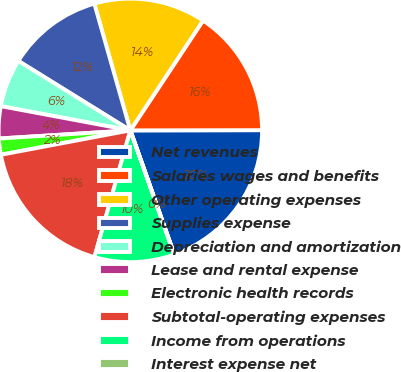Convert chart. <chart><loc_0><loc_0><loc_500><loc_500><pie_chart><fcel>Net revenues<fcel>Salaries wages and benefits<fcel>Other operating expenses<fcel>Supplies expense<fcel>Depreciation and amortization<fcel>Lease and rental expense<fcel>Electronic health records<fcel>Subtotal-operating expenses<fcel>Income from operations<fcel>Interest expense net<nl><fcel>19.6%<fcel>15.67%<fcel>13.71%<fcel>11.76%<fcel>5.89%<fcel>3.93%<fcel>1.98%<fcel>17.64%<fcel>9.8%<fcel>0.02%<nl></chart> 